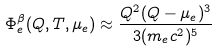<formula> <loc_0><loc_0><loc_500><loc_500>\Phi _ { e } ^ { \beta } ( Q , T , \mu _ { e } ) \approx \frac { Q ^ { 2 } ( Q - \mu _ { e } ) ^ { 3 } } { 3 ( m _ { e } c ^ { 2 } ) ^ { 5 } }</formula> 